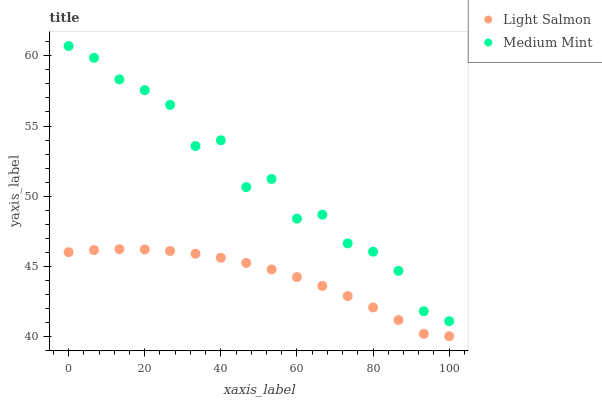Does Light Salmon have the minimum area under the curve?
Answer yes or no. Yes. Does Medium Mint have the maximum area under the curve?
Answer yes or no. Yes. Does Light Salmon have the maximum area under the curve?
Answer yes or no. No. Is Light Salmon the smoothest?
Answer yes or no. Yes. Is Medium Mint the roughest?
Answer yes or no. Yes. Is Light Salmon the roughest?
Answer yes or no. No. Does Light Salmon have the lowest value?
Answer yes or no. Yes. Does Medium Mint have the highest value?
Answer yes or no. Yes. Does Light Salmon have the highest value?
Answer yes or no. No. Is Light Salmon less than Medium Mint?
Answer yes or no. Yes. Is Medium Mint greater than Light Salmon?
Answer yes or no. Yes. Does Light Salmon intersect Medium Mint?
Answer yes or no. No. 